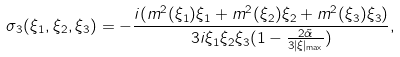Convert formula to latex. <formula><loc_0><loc_0><loc_500><loc_500>\sigma _ { 3 } ( \xi _ { 1 } , \xi _ { 2 } , \xi _ { 3 } ) = - \frac { i ( m ^ { 2 } ( \xi _ { 1 } ) \xi _ { 1 } + m ^ { 2 } ( \xi _ { 2 } ) \xi _ { 2 } + m ^ { 2 } ( \xi _ { 3 } ) \xi _ { 3 } ) } { 3 i \xi _ { 1 } \xi _ { 2 } \xi _ { 3 } ( 1 - \frac { 2 \tilde { \alpha } } { 3 | \xi | _ { \max } } ) } ,</formula> 